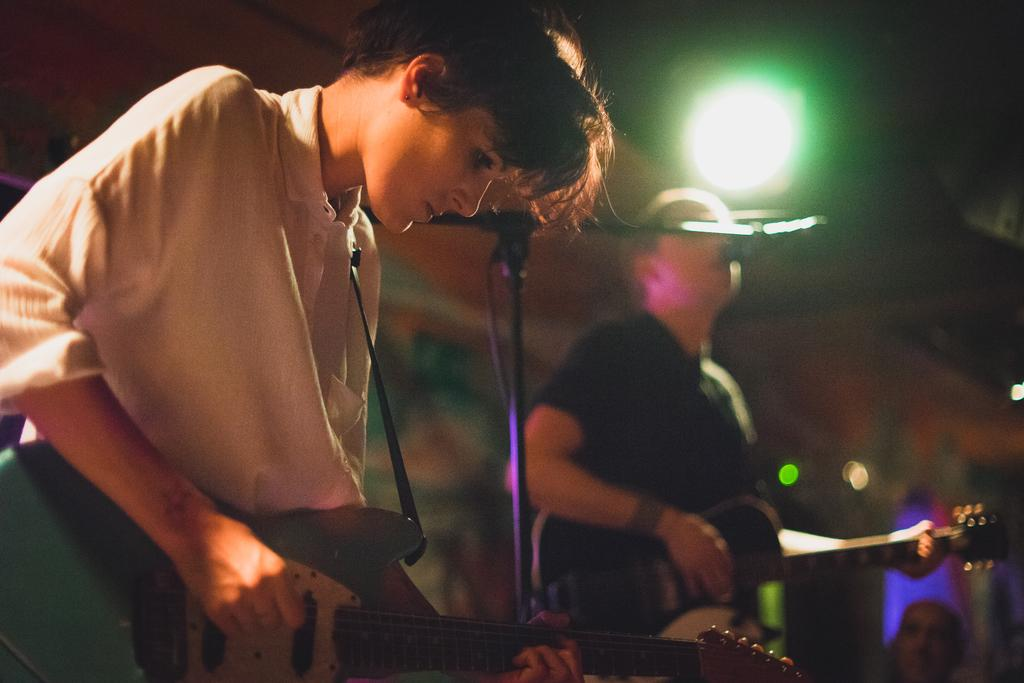What is the lady in the image doing? The lady is playing a guitar in the image. What can be seen near the lady? There is a mic stand in the image. What is the person in the image doing? The person is singing and playing a guitar. Can you describe the lighting in the image? There is a light in the image. What type of rice is being cooked on the stage in the image? There is no rice or stage present in the image. 